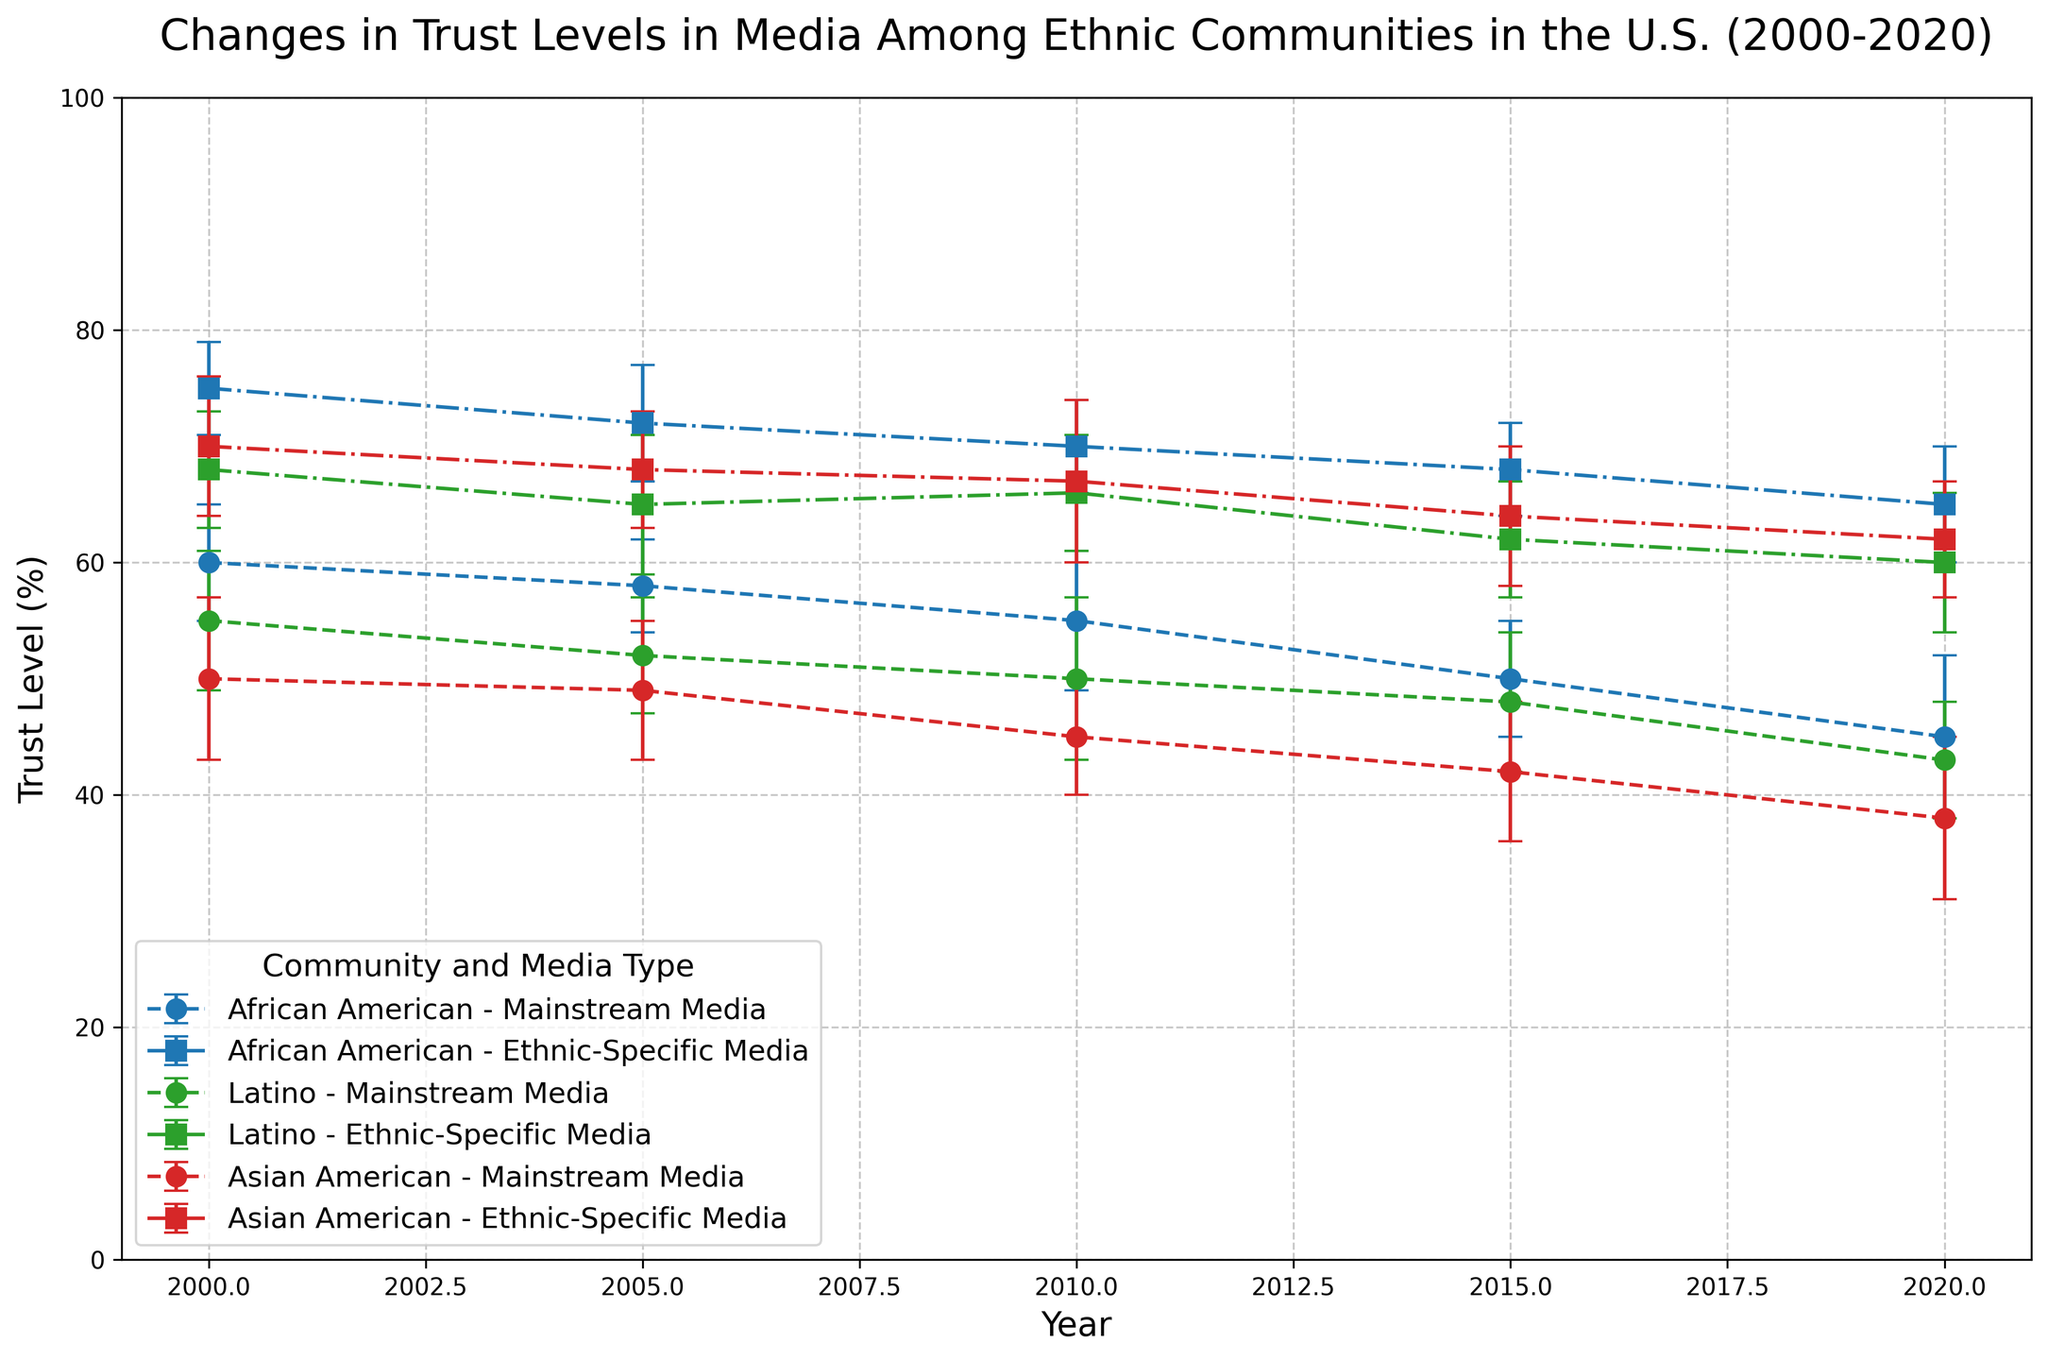What is the general trend in trust levels in mainstream media for African American communities from 2000 to 2020? From the figure, observe the trend line for African American communities for mainstream media. The trust level has decreased from 60% in 2000 to 45% in 2020. The overall trend is downward.
Answer: Decreasing Which ethnic community had the highest trust level in ethnic-specific media in 2020? From the figure, compare the trust levels of the ethnic-specific media for each community in 2020. African American had 65%, Latino had 60%, and Asian American had 62%. The highest trust level is in the African American community with 65%.
Answer: African American How does the trust level in ethnic-specific media for Latinos in 2010 compare to their trust level in mainstream media in 2000? In 2010, the trust level of Latinos in ethnic-specific media is 66%. In 2000, the trust level of Latinos in mainstream media is 55%. Therefore, the trust level in ethnic-specific media in 2010 is higher by 11%.
Answer: Higher by 11% What is the average trust level for African American communities in mainstream media across all years? Find the trust levels of African American communities in mainstream media for each year: 60, 58, 55, 50, and 45. Sum these values: 60 + 58 + 55 + 50 + 45 = 268. There are 5 data points, so the average is 268/5 = 53.6.
Answer: 53.6 Between African American and Asian American communities, which one showed a greater decrease in trust in mainstream media from 2000 to 2020? For African Americans, the trust level went from 60% in 2000 to 45% in 2020, a decrease of 15%. For Asian Americans, it went from 50% in 2000 to 38% in 2020, a decrease of 12%. Therefore, African Americans showed a greater decrease.
Answer: African American What is the difference in trust levels between mainstream and ethnic-specific media for the Latino community in 2020? In 2020, the trust level for the Latino community in mainstream media is 43%. In ethnic-specific media, it is 60%. The difference between these levels is 60% - 43% = 17%.
Answer: 17% Which community experienced the largest error bar in any year for mainstream media, and what was the error bar value? Scan the error bars for mainstream media for each community and each year. The largest error bar appears for Asian Americans in 2000 with a value of 7.
Answer: Asian American, 7 What is the combined trust level for all communities in ethnic-specific media in 2015? Find the trust levels for each community in ethnic-specific media in 2015: African American 68%, Latino 62%, Asian American 64%. Sum these values: 68 + 62 + 64 = 194.
Answer: 194 